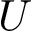<formula> <loc_0><loc_0><loc_500><loc_500>U</formula> 